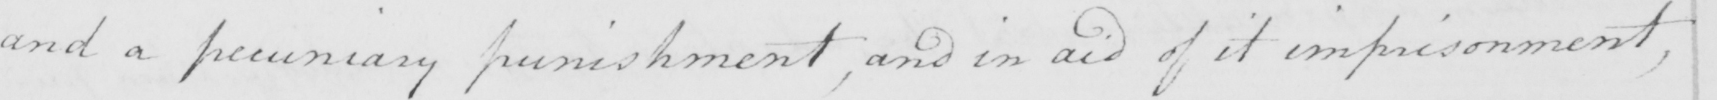Can you tell me what this handwritten text says? and a pecuniary punishment , and in aid of it imprisonment , 